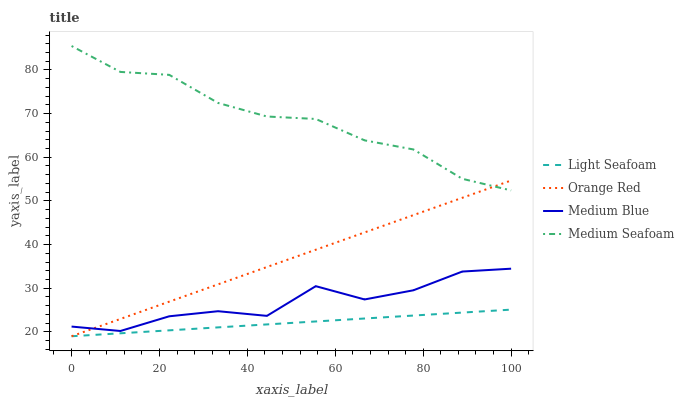Does Light Seafoam have the minimum area under the curve?
Answer yes or no. Yes. Does Medium Seafoam have the maximum area under the curve?
Answer yes or no. Yes. Does Medium Blue have the minimum area under the curve?
Answer yes or no. No. Does Medium Blue have the maximum area under the curve?
Answer yes or no. No. Is Light Seafoam the smoothest?
Answer yes or no. Yes. Is Medium Blue the roughest?
Answer yes or no. Yes. Is Orange Red the smoothest?
Answer yes or no. No. Is Orange Red the roughest?
Answer yes or no. No. Does Medium Blue have the lowest value?
Answer yes or no. No. Does Medium Seafoam have the highest value?
Answer yes or no. Yes. Does Medium Blue have the highest value?
Answer yes or no. No. Is Medium Blue less than Medium Seafoam?
Answer yes or no. Yes. Is Medium Blue greater than Light Seafoam?
Answer yes or no. Yes. Does Medium Seafoam intersect Orange Red?
Answer yes or no. Yes. Is Medium Seafoam less than Orange Red?
Answer yes or no. No. Is Medium Seafoam greater than Orange Red?
Answer yes or no. No. Does Medium Blue intersect Medium Seafoam?
Answer yes or no. No. 